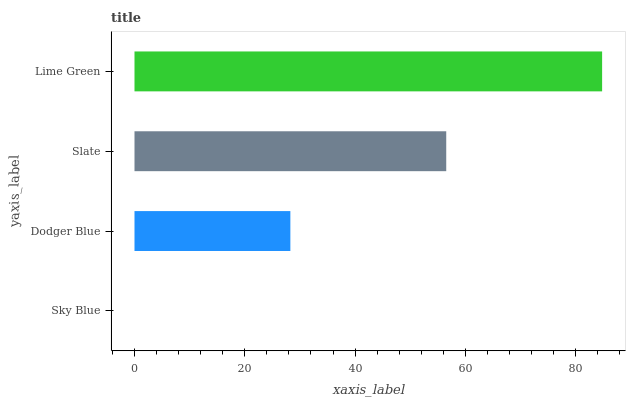Is Sky Blue the minimum?
Answer yes or no. Yes. Is Lime Green the maximum?
Answer yes or no. Yes. Is Dodger Blue the minimum?
Answer yes or no. No. Is Dodger Blue the maximum?
Answer yes or no. No. Is Dodger Blue greater than Sky Blue?
Answer yes or no. Yes. Is Sky Blue less than Dodger Blue?
Answer yes or no. Yes. Is Sky Blue greater than Dodger Blue?
Answer yes or no. No. Is Dodger Blue less than Sky Blue?
Answer yes or no. No. Is Slate the high median?
Answer yes or no. Yes. Is Dodger Blue the low median?
Answer yes or no. Yes. Is Sky Blue the high median?
Answer yes or no. No. Is Lime Green the low median?
Answer yes or no. No. 